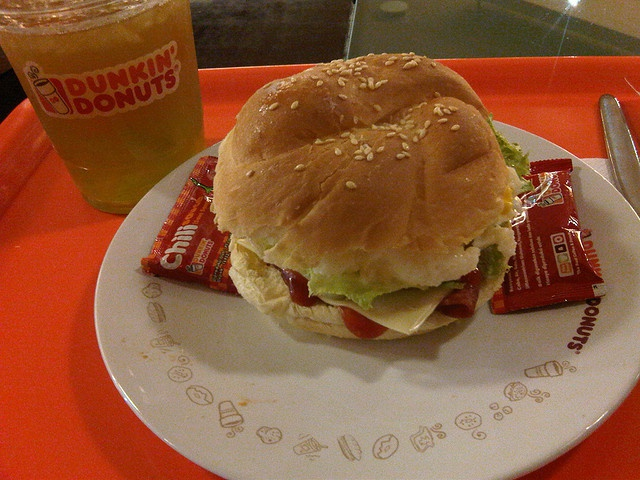Describe the objects in this image and their specific colors. I can see dining table in maroon, darkgray, brown, and tan tones, sandwich in brown, olive, maroon, and gray tones, cup in brown and maroon tones, and knife in brown, gray, and olive tones in this image. 